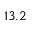Convert formula to latex. <formula><loc_0><loc_0><loc_500><loc_500>1 3 . 2</formula> 